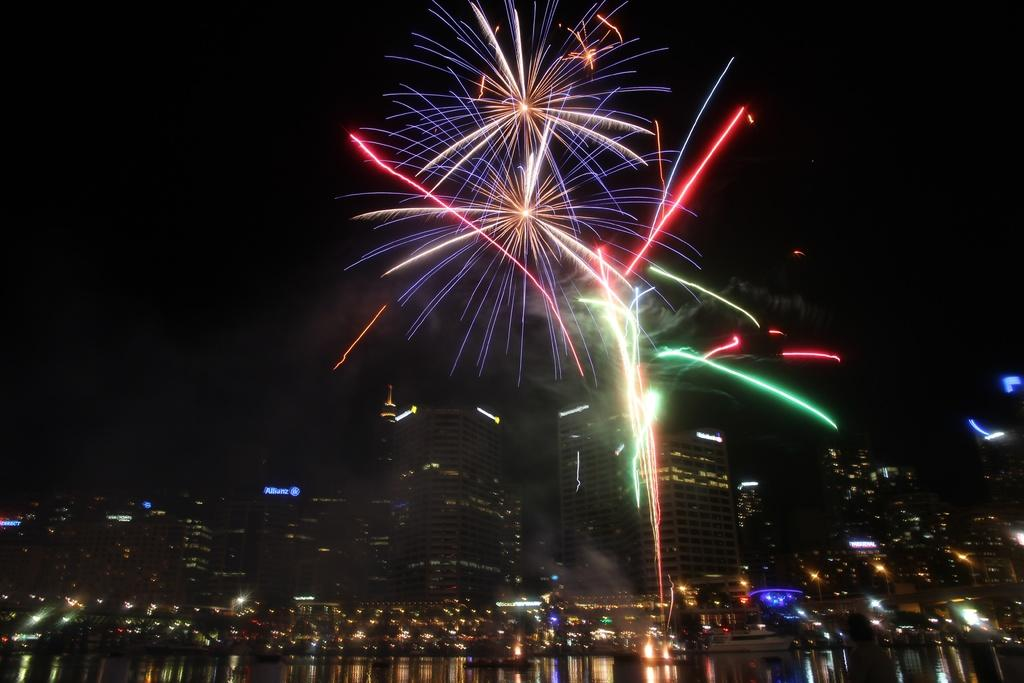What is at the bottom of the image? There is water at the bottom of the image. What can be seen in the background of the image? There are buildings in the background of the image. What is happening in the sky in the image? There are fireworks in the sky. Can you tell me who the judge is in the image? There is no judge present in the image. How many people are kissing in the image? There are no people kissing in the image. 